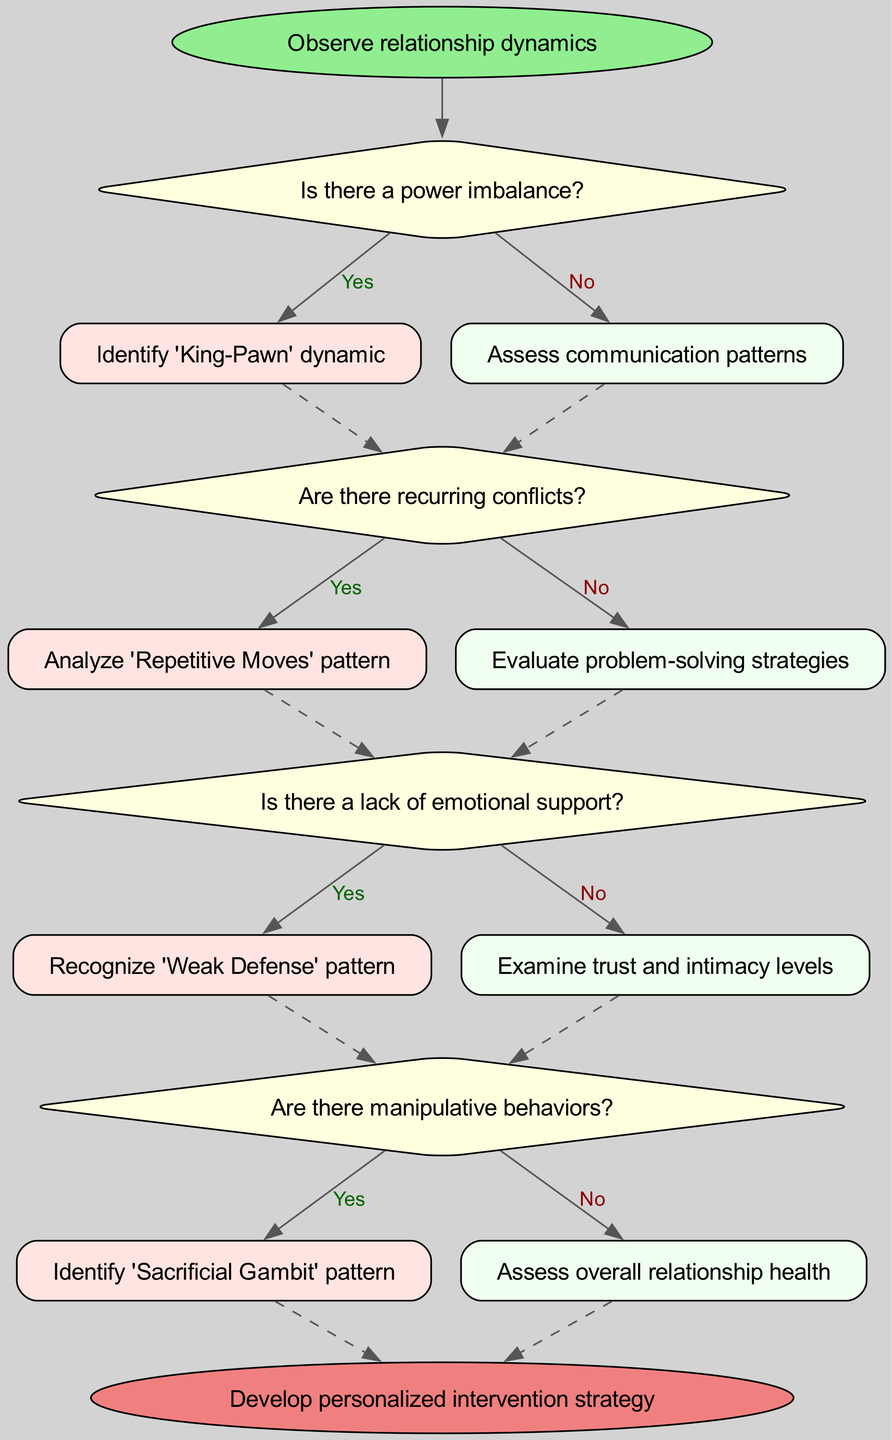What is the first step in the process? The diagram begins with the node labeled "Observe relationship dynamics", which indicates the initial action to take.
Answer: Observe relationship dynamics How many decision points are there in the process? The diagram includes four decision nodes labeled as decision1, decision2, decision3, and decision4, indicating four distinct points where action is determined.
Answer: 4 What happens if there is a power imbalance? If the answer to decision1 ("Is there a power imbalance?") is Yes, the next step is to "Identify 'King-Pawn' dynamic".
Answer: Identify 'King-Pawn' dynamic What do you assess if there is no power imbalance? When the answer to decision1 is No, the next step is to "Assess communication patterns".
Answer: Assess communication patterns What pattern is recognized when there is a lack of emotional support? If the answer to decision3 ("Is there a lack of emotional support?") is Yes, the next step is to "Recognize 'Weak Defense' pattern".
Answer: Recognize 'Weak Defense' pattern How do you proceed if there are manipulative behaviors? If there are manipulative behaviors (answer to decision4 is Yes), the next action is to "Identify 'Sacrificial Gambit' pattern".
Answer: Identify 'Sacrificial Gambit' pattern Which decision leads to a final intervention strategy? The flow ends at the node labeled "Develop personalized intervention strategy", which comes from multiple potential paths based on answers.
Answer: Develop personalized intervention strategy What is evaluated if there are no recurring conflicts? If the answer to decision2 is No, the process continues to "Evaluate problem-solving strategies".
Answer: Evaluate problem-solving strategies What is the final output node representing? The final output node is labeled "Develop personalized intervention strategy", indicating the ultimate goal of the process based on the evaluations and decisions made.
Answer: Develop personalized intervention strategy 